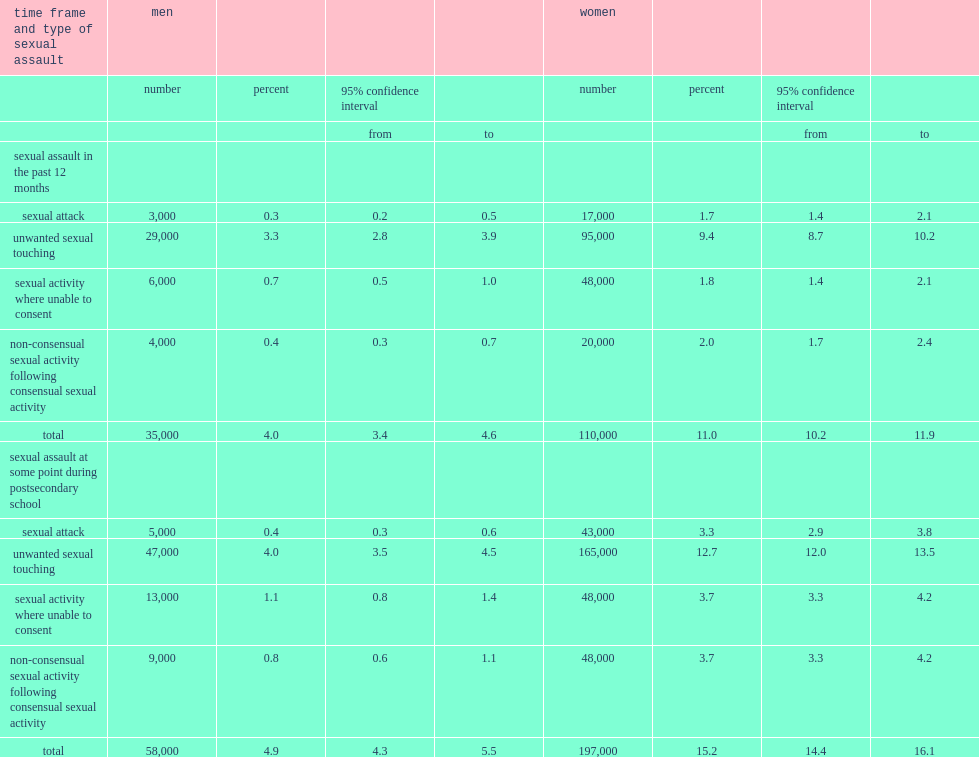How many percent of women who were attending postsecondary school during the time indicated that they had been sexually assaulted in the postsecondary setting in the preceding year? 11.0. How many individual women students who were attending postsecondary school during the time indicated that they had been sexually assaulted in the postsecondary setting in the preceding year? 110000.0. What was the proportion among men? 4.0. How many percent of women who stated that they had been sexually assaulted in the postsecondary setting at one time during their time at school? 15.2. How many women who sexually assaulted in the postsecondary setting at one time during their time at schoo? 197000.0. How many times were women who sexually assaulted in the postsecondary setting at one time during their time at school higher than among men? 3.102041. 